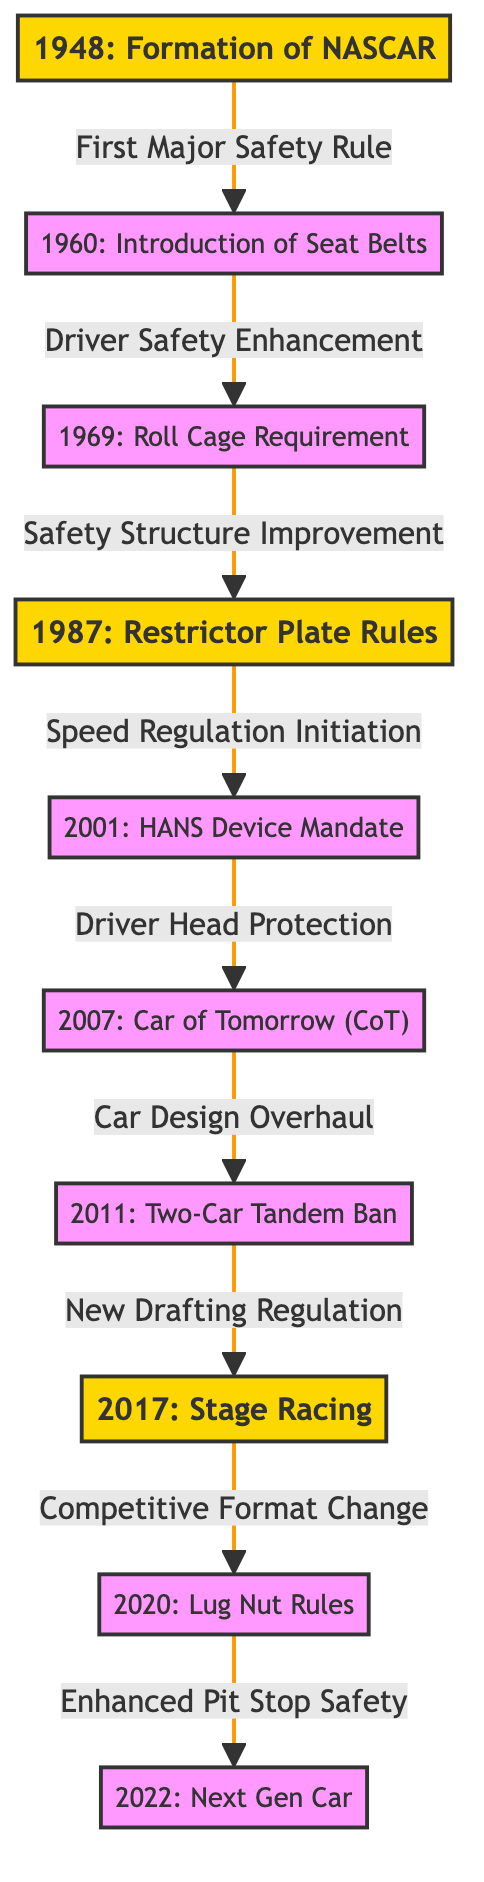What year did NASCAR first form? The diagram presents specific nodes labeled with years, and one of them indicates "1948: Formation of NASCAR." Therefore, the answer can be found directly on the node.
Answer: 1948 What was introduced in 1960? The node corresponding to 1960 is labeled "Introduction of Seat Belts." This is a clear piece of information laid out in the diagram under that year.
Answer: Introduction of Seat Belts How many major changes are listed from 1948 to 2022? By counting the main nodes in the diagram from the starting node in 1948 to the last node in 2022, I find there are a total of 10 distinct nodes representing major changes over the decades.
Answer: 10 What safety feature was mandated in 2001? The diagram indicates that in 2001, the "HANS Device Mandate" was implemented, which is specifically noted as a measure for driver safety enhancements. Therefore, the key safety feature can be identified easily.
Answer: HANS Device Mandate Which two years correspond to major changes related to safety? To answer this, I look for the nodes that specifically mention safety. The nodes for 1960 (Seat Belts) and 2001 (HANS Device Mandate) both emphasize enhancements in safety, making them relevant to the question.
Answer: 1960, 2001 What relationship exists between the years 1987 and 2001? The diagram shows an arrow indicating a directional relationship between the node labeled 1987 ("Restrictor Plate Rules") and the node labeled 2001 ("HANS Device Mandate"). The connecting phrase is "Speed Regulation Initiation," showing the logical flow from one rule to another.
Answer: Speed Regulation Initiation What significant design change occurred in 2007? The node for 2007 reads "Car of Tomorrow (CoT)," which signifies a major overhaul in car design. This information is clearly outlined in the diagram under the corresponding year node.
Answer: Car of Tomorrow (CoT) What competitive format change took place in 2017? The diagram states that in 2017, there was an introduction of "Stage Racing." This is explicitly mentioned and shows the significant alteration in how races are structured.
Answer: Stage Racing How did the introduction of Lug Nut Rules in 2020 impact safety? From the diagram, it indicates that in 2020, the rules were aimed at "Enhanced Pit Stop Safety." This implies that the changes were directly related to improving safety during pit stops, linking the introduction of Lug Nut Rules to this objective.
Answer: Enhanced Pit Stop Safety 